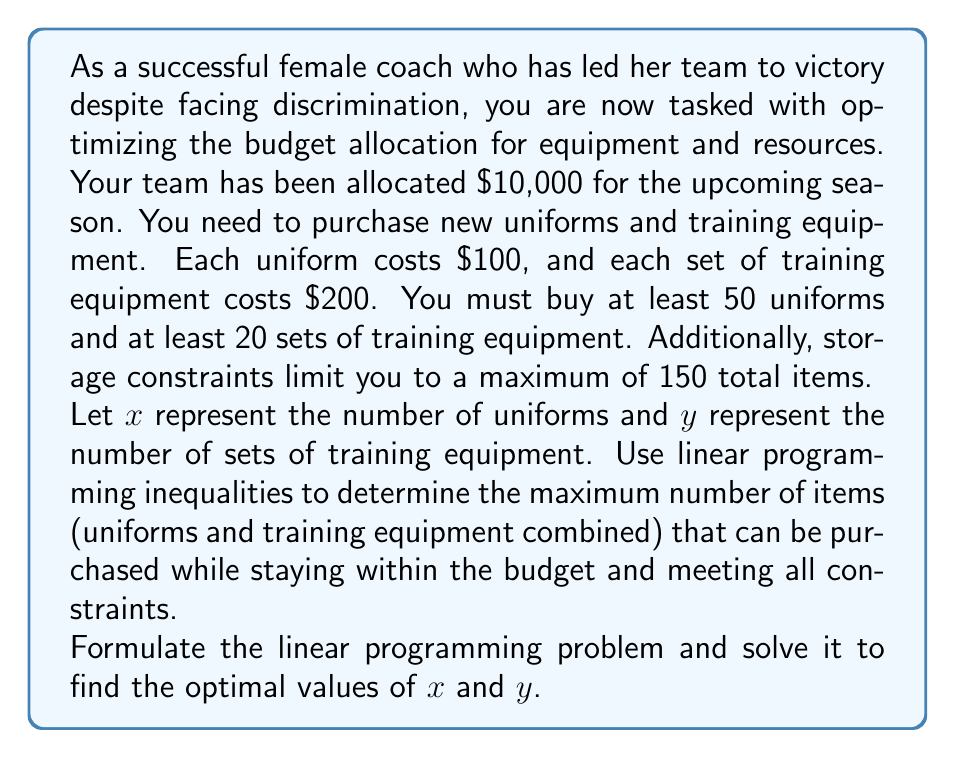Give your solution to this math problem. Let's approach this step-by-step:

1) First, we need to formulate the linear programming inequalities:

   Budget constraint: $100x + 200y \leq 10000$
   Minimum uniforms: $x \geq 50$
   Minimum training equipment: $y \geq 20$
   Storage constraint: $x + y \leq 150$
   Non-negativity: $x \geq 0, y \geq 0$

2) Our objective is to maximize $x + y$ subject to these constraints.

3) We can solve this graphically by plotting the constraints:

   [asy]
   import geometry;

   size(200);
   
   xlimits(0,150);
   ylimits(0,75);
   
   xaxis("x",Arrow);
   yaxis("y",Arrow);

   draw((0,50)--(100,50),blue);
   draw((50,0)--(50,75),blue);
   draw((20,0)--(20,75),red);
   draw((0,65)--(100,15),green);
   draw((0,150)--(150,0),purple);

   label("x=50",(50,70),E);
   label("y=20",(15,20),W);
   label("100x+200y=10000",(80,10),SE);
   label("x+y=150",(130,20),SE);

   dot((50,20));
   dot((75,37.5));
   dot((100,25));

   label("(50,20)",(50,20),SE);
   label("(75,37.5)",(75,37.5),SE);
   label("(100,25)",(100,25),NW);
   [/asy]

4) The feasible region is the area bounded by these lines. The optimal solution will be at one of the corner points of this region.

5) The corner points are (50,20), (75,37.5), and (100,25).

6) Evaluating $x + y$ at each point:
   (50,20): 50 + 20 = 70
   (75,37.5): 75 + 37.5 = 112.5
   (100,25): 100 + 25 = 125

7) The maximum value is achieved at the point (100,25).

Therefore, the optimal solution is to purchase 100 uniforms and 25 sets of training equipment, for a total of 125 items.
Answer: The maximum number of items that can be purchased is 125, consisting of 100 uniforms ($x = 100$) and 25 sets of training equipment ($y = 25$). 